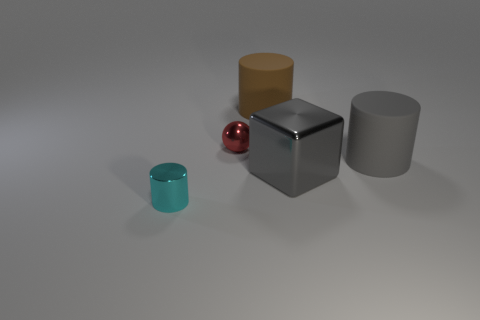Are there fewer gray cubes than tiny purple matte cubes?
Keep it short and to the point. No. The small metal thing that is behind the big matte thing that is to the right of the large rubber cylinder behind the large gray rubber cylinder is what shape?
Offer a terse response. Sphere. Is there a small purple cube made of the same material as the brown cylinder?
Your answer should be very brief. No. Do the small thing behind the tiny cyan metallic cylinder and the large cylinder in front of the brown thing have the same color?
Your answer should be compact. No. Is the number of red shiny objects that are to the left of the tiny cyan metallic cylinder less than the number of large cyan balls?
Make the answer very short. No. What number of things are either tiny metal things or large rubber cylinders in front of the brown cylinder?
Provide a succinct answer. 3. What color is the large thing that is made of the same material as the red sphere?
Offer a very short reply. Gray. What number of things are large yellow things or red things?
Provide a short and direct response. 1. The cylinder that is the same size as the red ball is what color?
Offer a very short reply. Cyan. How many things are large matte objects in front of the tiny red ball or red blocks?
Ensure brevity in your answer.  1. 